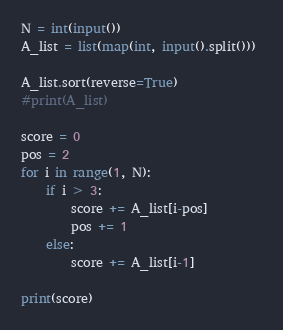Convert code to text. <code><loc_0><loc_0><loc_500><loc_500><_Python_>N = int(input())
A_list = list(map(int, input().split())) 

A_list.sort(reverse=True)
#print(A_list)

score = 0
pos = 2
for i in range(1, N):
    if i > 3:
        score += A_list[i-pos]
        pos += 1
    else:
        score += A_list[i-1]

print(score)
</code> 